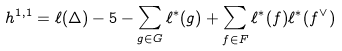<formula> <loc_0><loc_0><loc_500><loc_500>h ^ { 1 , 1 } = \ell ( \Delta ) - 5 - \sum _ { g \in G } \ell ^ { * } ( g ) + \sum _ { f \in F } \ell ^ { * } ( f ) \ell ^ { * } ( f ^ { \vee } )</formula> 